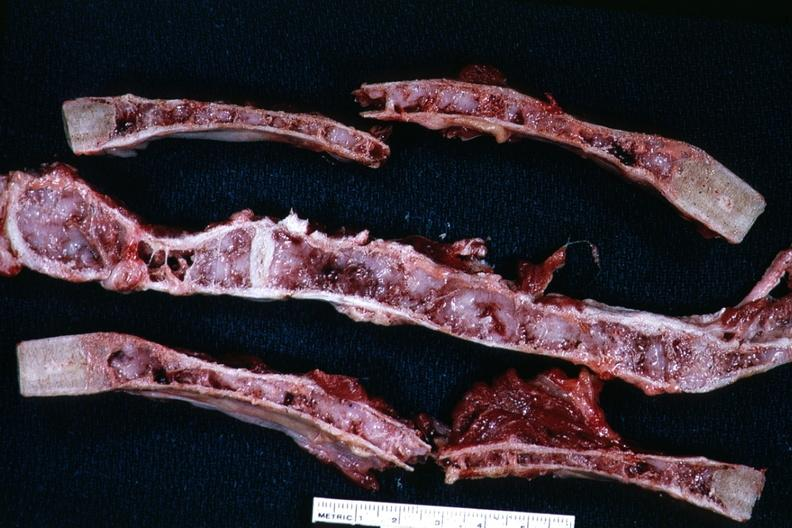what does this image show?
Answer the question using a single word or phrase. Saggital sections rather close up near if not natural color excellent example myeloma lesions in marrow 